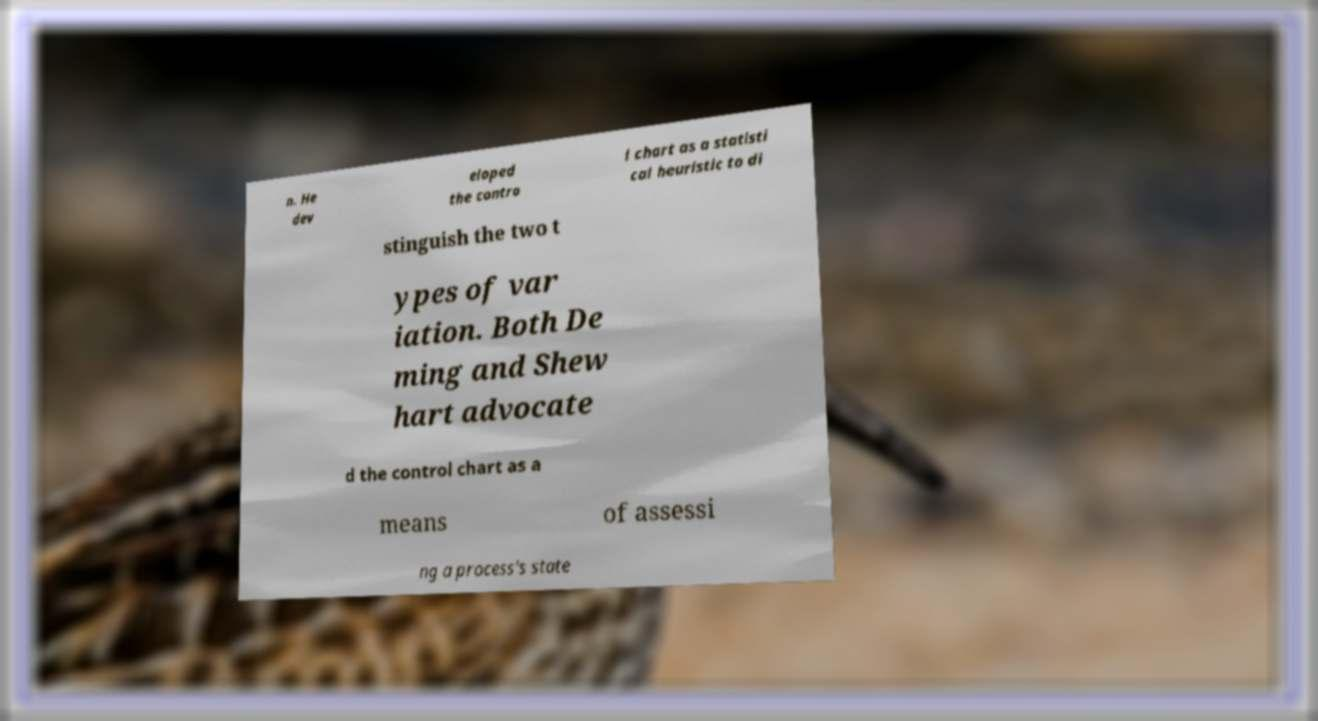I need the written content from this picture converted into text. Can you do that? n. He dev eloped the contro l chart as a statisti cal heuristic to di stinguish the two t ypes of var iation. Both De ming and Shew hart advocate d the control chart as a means of assessi ng a process's state 